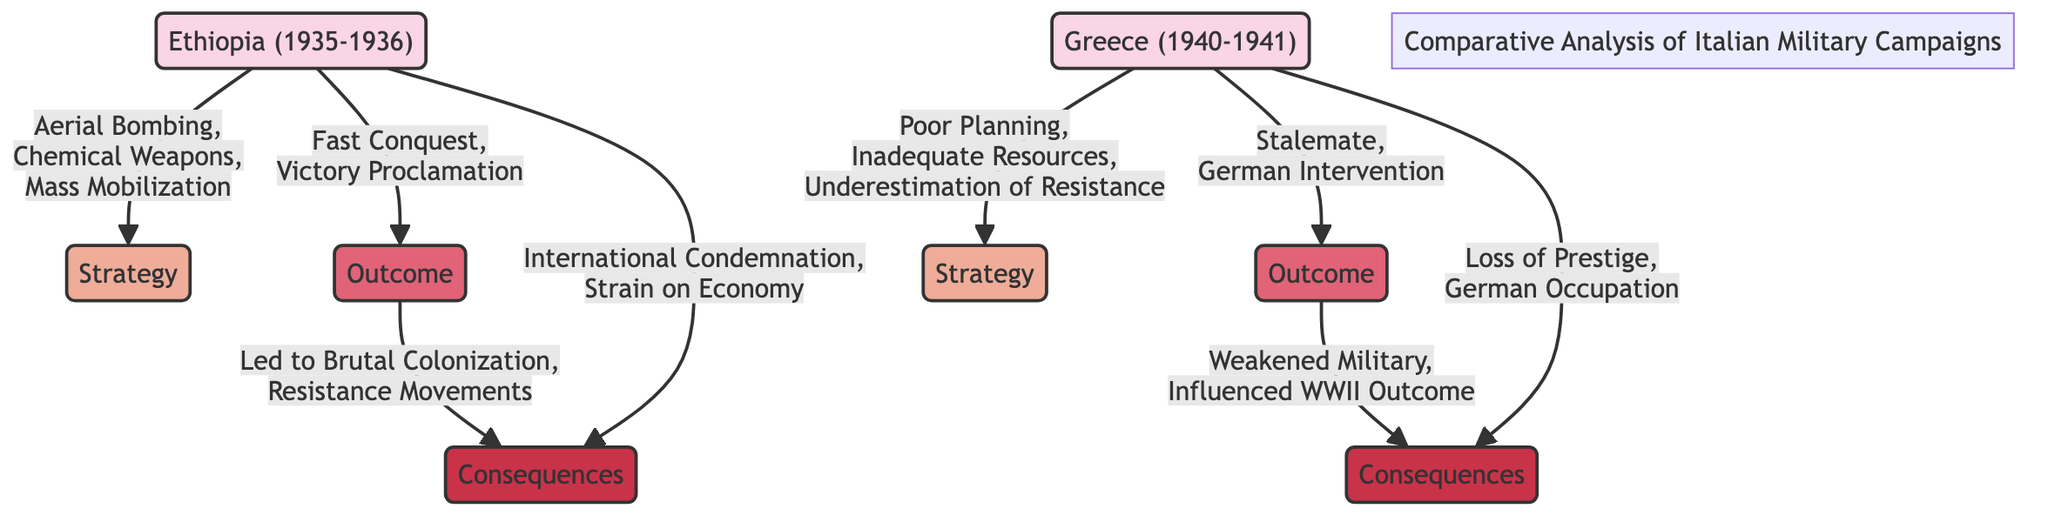What strategies were employed in the Ethiopian campaign? The diagram indicates that the strategies used in the Ethiopian campaign included Aerial Bombing, Chemical Weapons, and Mass Mobilization. These strategies are directly listed under the StrategyEthiopia node.
Answer: Aerial Bombing, Chemical Weapons, Mass Mobilization What was the outcome of the Greek campaign? According to the diagram, the outcome of the Greek campaign was a Stalemate and German Intervention, which can be found under the OutcomeGreece node.
Answer: Stalemate, German Intervention Which campaign resulted in international condemnation? The diagram specifies that the Ethiopian campaign led to International Condemnation, indicated in the ConsequencesEthiopia node. The arrow connects the OutcomeEthiopia to the ConsequencesEthiopia.
Answer: International Condemnation How did the outcome of the Ethiopian campaign affect its consequences? The outcome of the Ethiopian campaign, which was a Fast Conquest and Victory Proclamation, led to consequences including Brutal Colonization and Resistance Movements, as shown in the flow from OutcomeEthiopia to ConsequencesEthiopia in the diagram.
Answer: Brutal Colonization, Resistance Movements What was a key strategy used in the Greek campaign? The diagram indicates that a key strategy in the Greek campaign was Poor Planning, along with Inadequate Resources and Underestimation of Resistance, which are stated under the StrategyGreece node.
Answer: Poor Planning What was one of the consequences of the Greek campaign? As illustrated in the diagram, one consequence of the Greek campaign was Loss of Prestige, which is listed under the ConsequencesGreece node.
Answer: Loss of Prestige Were the strategies in the Ethiopian campaign effective? Yes, the strategies of Aerial Bombing, Chemical Weapons, and Mass Mobilization led to a Fast Conquest and a Victory Proclamation, showing effectiveness as represented in the flow from StrategyEthiopia to OutcomeEthiopia.
Answer: Yes What is the total number of strategies listed for the Ethiopian and Greek campaigns combined? The Ethiopian campaign has three strategies, and the Greek campaign has three strategies, making a total of six strategies in the diagram.
Answer: 6 How did the Ethiopian campaign influence military legacy? The Ethiopian campaign influenced military legacy through its outcomes that resulted in Resistance Movements and Brutal Colonization, which are connected in the diagram. The conflict is depicted in the flow linking OutcomeEthiopia to ConsequencesEthiopia.
Answer: Resistance Movements, Brutal Colonization 